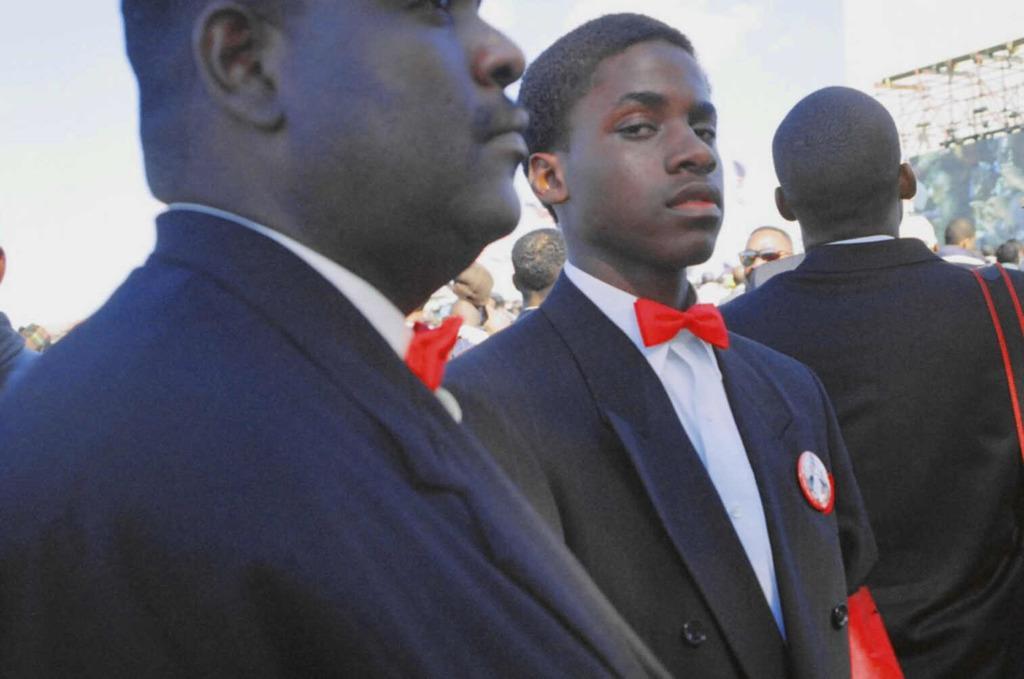Please provide a concise description of this image. In this image we can see people. These people wore suits. 